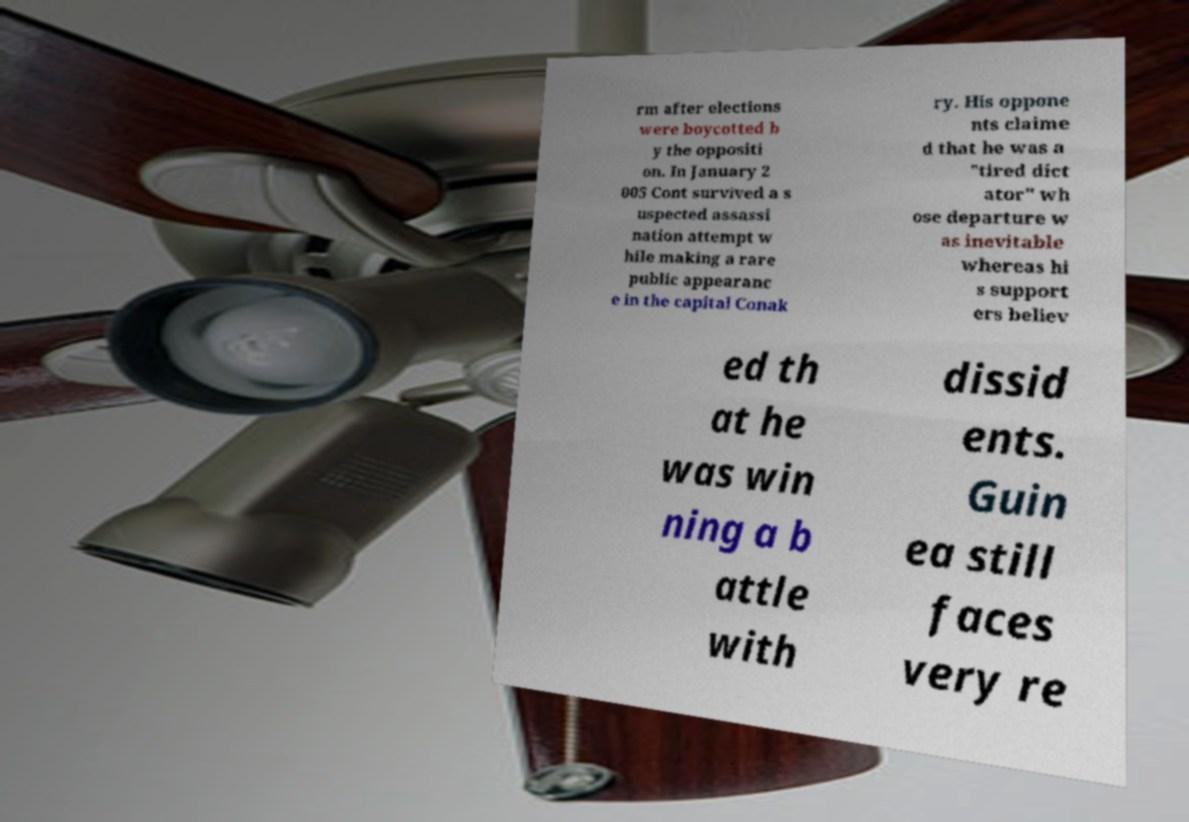Can you accurately transcribe the text from the provided image for me? rm after elections were boycotted b y the oppositi on. In January 2 005 Cont survived a s uspected assassi nation attempt w hile making a rare public appearanc e in the capital Conak ry. His oppone nts claime d that he was a "tired dict ator" wh ose departure w as inevitable whereas hi s support ers believ ed th at he was win ning a b attle with dissid ents. Guin ea still faces very re 